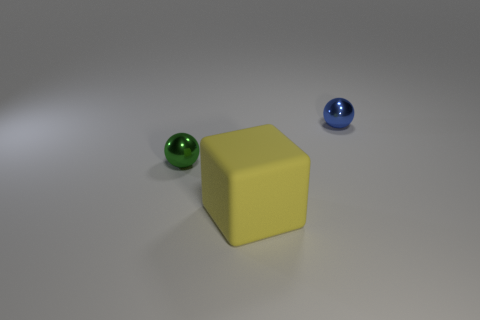Are there any other things that are made of the same material as the block?
Keep it short and to the point. No. There is a small green object that is made of the same material as the blue thing; what is its shape?
Offer a terse response. Sphere. How many large objects are brown cylinders or blue objects?
Give a very brief answer. 0. What number of balls are on the right side of the tiny thing that is in front of the metallic thing on the right side of the large thing?
Your answer should be compact. 1. There is a matte object that is right of the green metal ball; is its size the same as the small blue metal thing?
Your answer should be very brief. No. Are there fewer metallic objects to the left of the rubber thing than big yellow rubber blocks that are behind the green sphere?
Provide a succinct answer. No. Are there fewer big cubes that are on the left side of the tiny green ball than tiny shiny cylinders?
Give a very brief answer. No. Is the material of the big yellow thing the same as the small green ball?
Provide a short and direct response. No. How many balls are made of the same material as the big block?
Keep it short and to the point. 0. There is another ball that is made of the same material as the green sphere; what color is it?
Offer a terse response. Blue. 